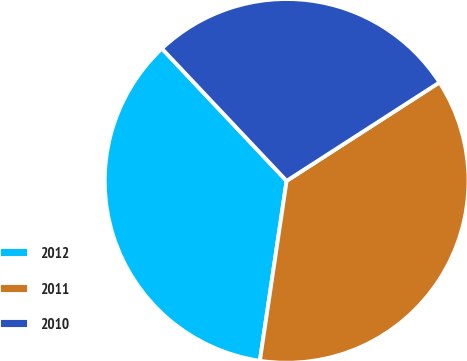Convert chart to OTSL. <chart><loc_0><loc_0><loc_500><loc_500><pie_chart><fcel>2012<fcel>2011<fcel>2010<nl><fcel>35.62%<fcel>36.46%<fcel>27.92%<nl></chart> 